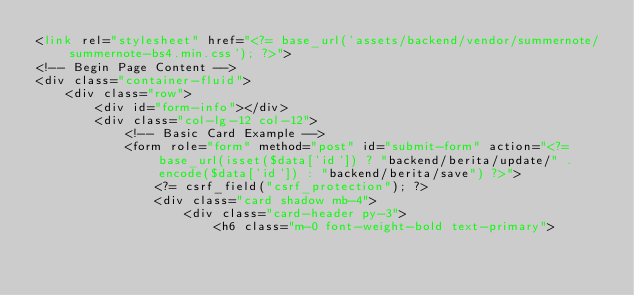<code> <loc_0><loc_0><loc_500><loc_500><_PHP_><link rel="stylesheet" href="<?= base_url('assets/backend/vendor/summernote/summernote-bs4.min.css'); ?>">
<!-- Begin Page Content -->
<div class="container-fluid">
    <div class="row">
        <div id="form-info"></div>
        <div class="col-lg-12 col-12">
            <!-- Basic Card Example -->
            <form role="form" method="post" id="submit-form" action="<?= base_url(isset($data['id']) ? "backend/berita/update/" . encode($data['id']) : "backend/berita/save") ?>">
                <?= csrf_field("csrf_protection"); ?>
                <div class="card shadow mb-4">
                    <div class="card-header py-3">
                        <h6 class="m-0 font-weight-bold text-primary"></code> 